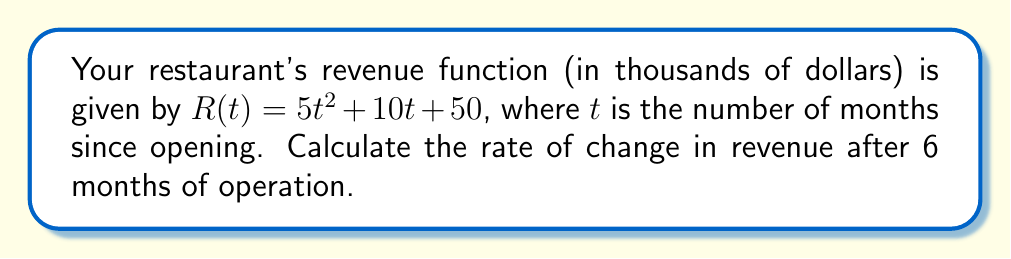Solve this math problem. To find the rate of change in revenue after 6 months, we need to calculate the derivative of the revenue function and evaluate it at $t = 6$. 

Step 1: Find the derivative of $R(t)$
$$\frac{d}{dt}R(t) = \frac{d}{dt}(5t^2 + 10t + 50)$$
$$R'(t) = 10t + 10$$

Step 2: Evaluate $R'(t)$ at $t = 6$
$$R'(6) = 10(6) + 10$$
$$R'(6) = 60 + 10 = 70$$

The rate of change is 70 thousand dollars per month after 6 months of operation.
Answer: $70$ thousand dollars per month 